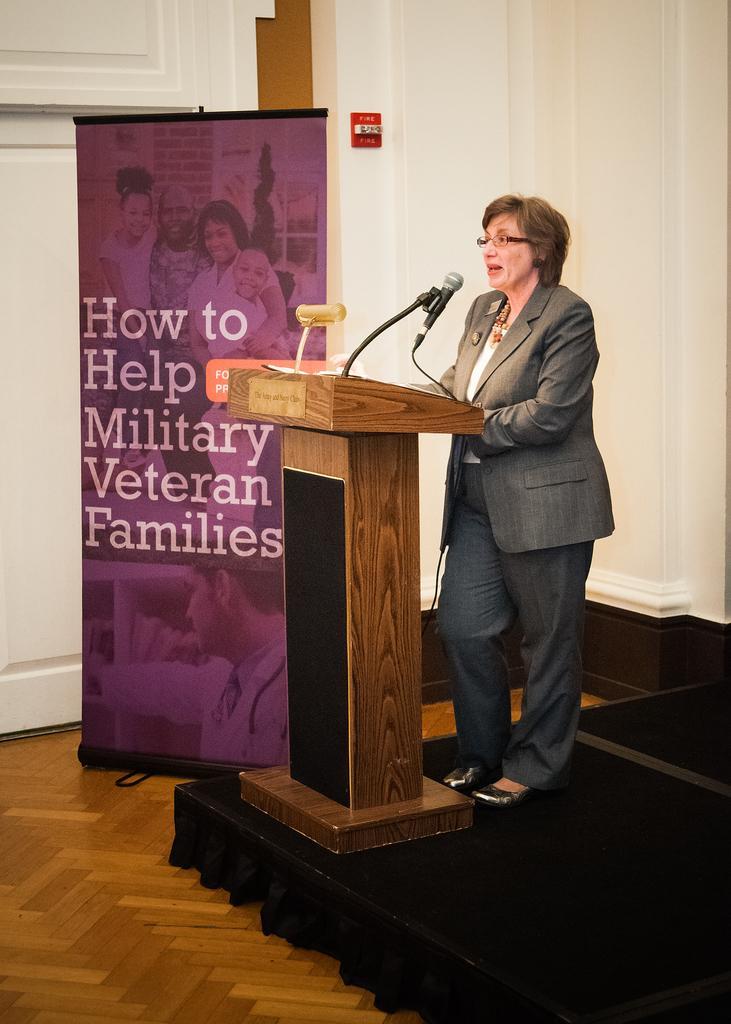Can you describe this image briefly? In this image there is a women standing on a stage, in front of a podium on that podium there are mice, in the background there is a poster on that poster there is some text. 